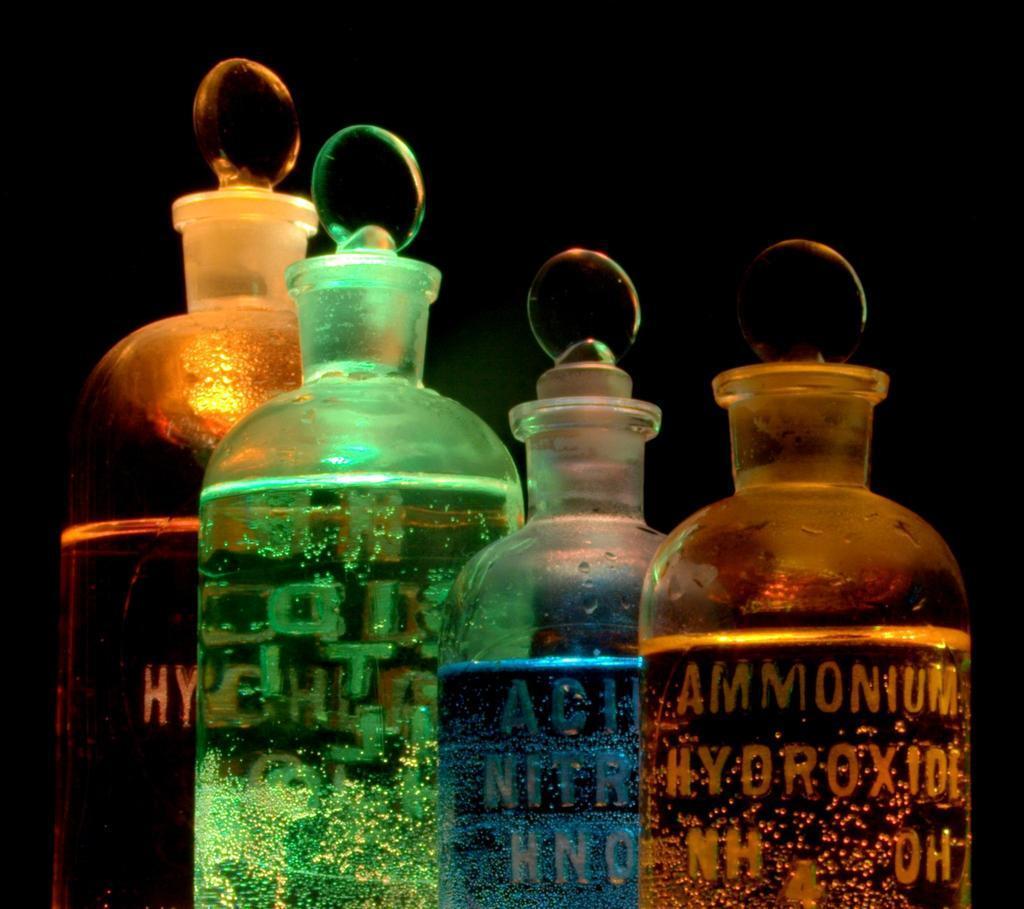In one or two sentences, can you explain what this image depicts? Four bottles are there some liquids present in them one is in blue colour another one is in green colour. Four are sealed with caps. 